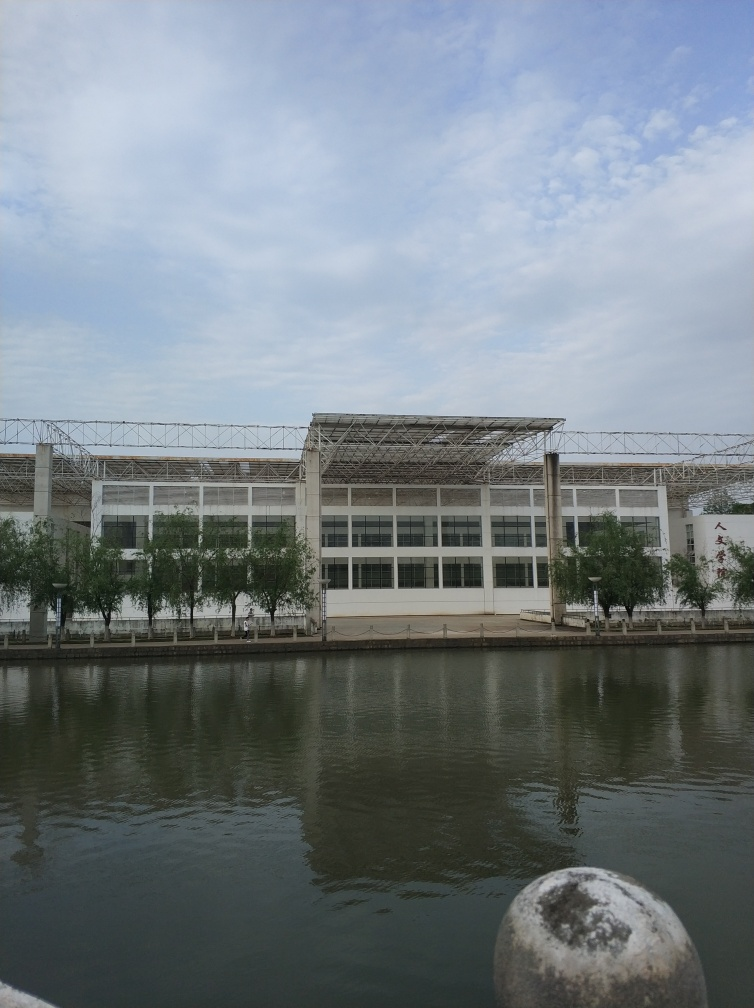How does the presence of the building affect the scenery of the waterfront? The building presents a modern juxtaposition against the natural landscape of the water, creating a contrasting environment where human-made structures and nature coexist. Its large windows and white facade reflect on the water, adding an element of symmetry and doubling the visual impact of the structure. 